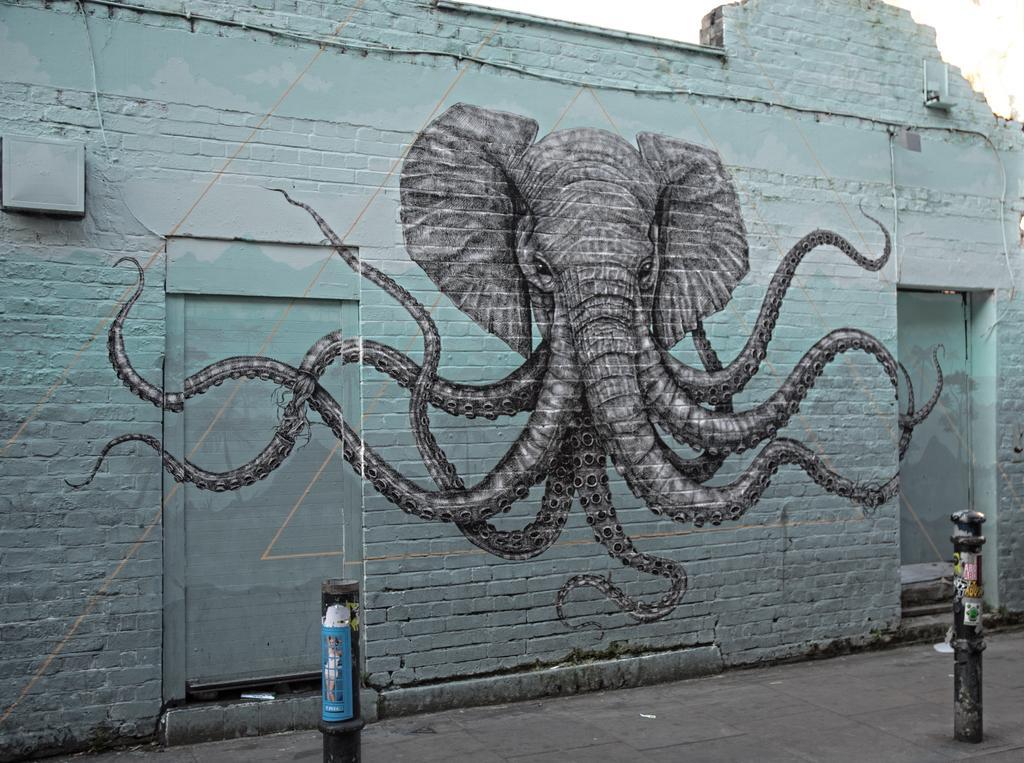Could you give a brief overview of what you see in this image? In this picture we can see a wall and on the wall there is elephant graffiti. In front of the wall there are two poles. 